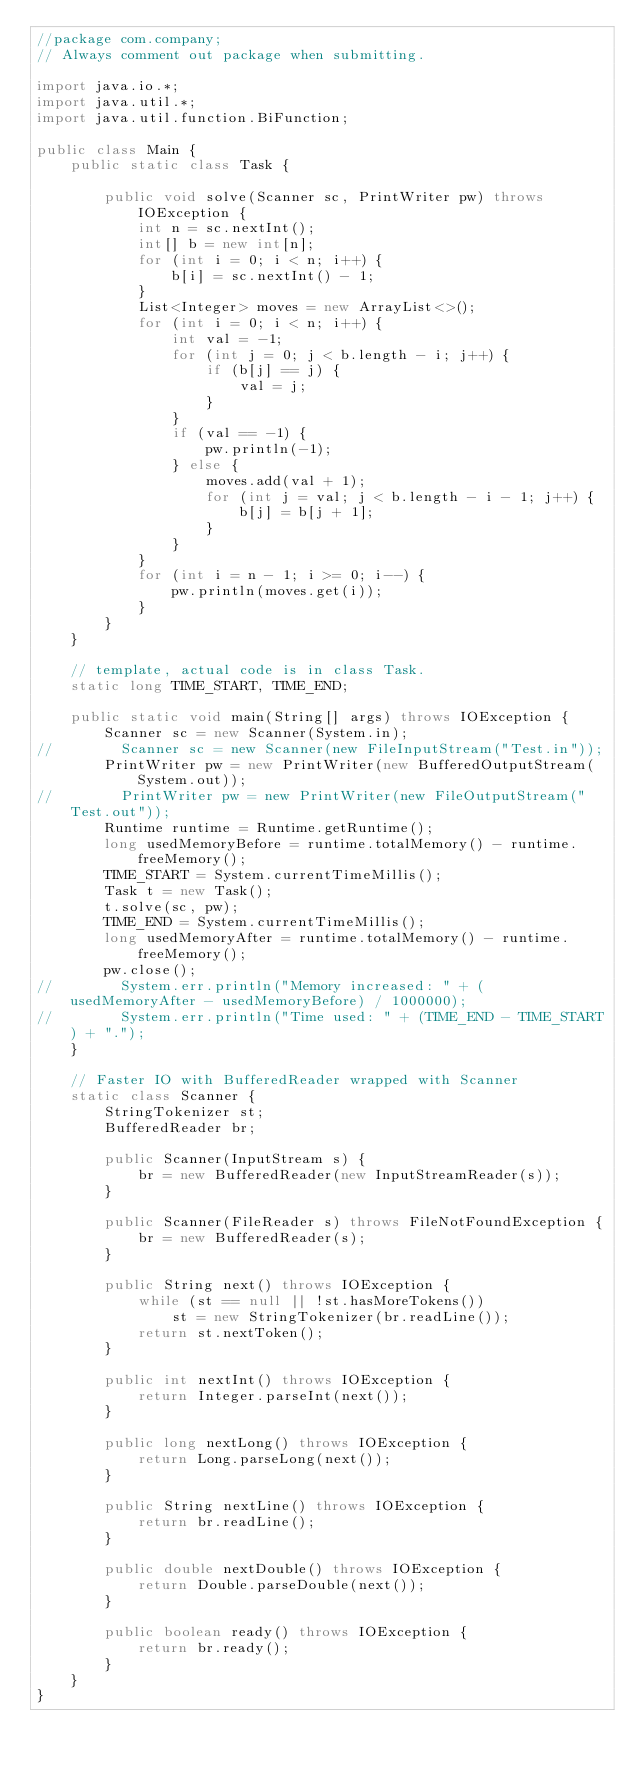<code> <loc_0><loc_0><loc_500><loc_500><_Java_>//package com.company;
// Always comment out package when submitting.

import java.io.*;
import java.util.*;
import java.util.function.BiFunction;

public class Main {
    public static class Task {

        public void solve(Scanner sc, PrintWriter pw) throws IOException {
            int n = sc.nextInt();
            int[] b = new int[n];
            for (int i = 0; i < n; i++) {
                b[i] = sc.nextInt() - 1;
            }
            List<Integer> moves = new ArrayList<>();
            for (int i = 0; i < n; i++) {
                int val = -1;
                for (int j = 0; j < b.length - i; j++) {
                    if (b[j] == j) {
                        val = j;
                    }
                }
                if (val == -1) {
                    pw.println(-1);
                } else {
                    moves.add(val + 1);
                    for (int j = val; j < b.length - i - 1; j++) {
                        b[j] = b[j + 1];
                    }
                }
            }
            for (int i = n - 1; i >= 0; i--) {
                pw.println(moves.get(i));
            }
        }
    }

    // template, actual code is in class Task.
    static long TIME_START, TIME_END;

    public static void main(String[] args) throws IOException {
        Scanner sc = new Scanner(System.in);
//        Scanner sc = new Scanner(new FileInputStream("Test.in"));
        PrintWriter pw = new PrintWriter(new BufferedOutputStream(System.out));
//        PrintWriter pw = new PrintWriter(new FileOutputStream("Test.out"));
        Runtime runtime = Runtime.getRuntime();
        long usedMemoryBefore = runtime.totalMemory() - runtime.freeMemory();
        TIME_START = System.currentTimeMillis();
        Task t = new Task();
        t.solve(sc, pw);
        TIME_END = System.currentTimeMillis();
        long usedMemoryAfter = runtime.totalMemory() - runtime.freeMemory();
        pw.close();
//        System.err.println("Memory increased: " + (usedMemoryAfter - usedMemoryBefore) / 1000000);
//        System.err.println("Time used: " + (TIME_END - TIME_START) + ".");
    }

    // Faster IO with BufferedReader wrapped with Scanner
    static class Scanner {
        StringTokenizer st;
        BufferedReader br;

        public Scanner(InputStream s) {
            br = new BufferedReader(new InputStreamReader(s));
        }

        public Scanner(FileReader s) throws FileNotFoundException {
            br = new BufferedReader(s);
        }

        public String next() throws IOException {
            while (st == null || !st.hasMoreTokens())
                st = new StringTokenizer(br.readLine());
            return st.nextToken();
        }

        public int nextInt() throws IOException {
            return Integer.parseInt(next());
        }

        public long nextLong() throws IOException {
            return Long.parseLong(next());
        }

        public String nextLine() throws IOException {
            return br.readLine();
        }

        public double nextDouble() throws IOException {
            return Double.parseDouble(next());
        }

        public boolean ready() throws IOException {
            return br.ready();
        }
    }
}</code> 